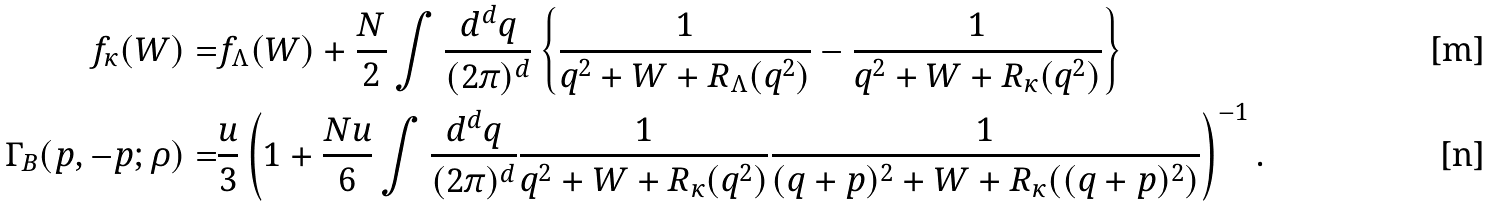Convert formula to latex. <formula><loc_0><loc_0><loc_500><loc_500>f _ { \kappa } ( W ) = & f _ { \Lambda } ( W ) + \frac { N } { 2 } \int \frac { d ^ { d } q } { ( 2 \pi ) ^ { d } } \left \{ \frac { 1 } { q ^ { 2 } + W + R _ { \Lambda } ( q ^ { 2 } ) } - \frac { 1 } { q ^ { 2 } + W + R _ { \kappa } ( q ^ { 2 } ) } \right \} \\ \Gamma _ { B } ( p , - p ; \rho ) = & \frac { u } { 3 } \left ( 1 + \frac { N u } { 6 } \int \frac { d ^ { d } q } { ( 2 \pi ) ^ { d } } \frac { 1 } { q ^ { 2 } + W + R _ { \kappa } ( q ^ { 2 } ) } \frac { 1 } { ( q + p ) ^ { 2 } + W + R _ { \kappa } ( ( q + p ) ^ { 2 } ) } \right ) ^ { - 1 } .</formula> 